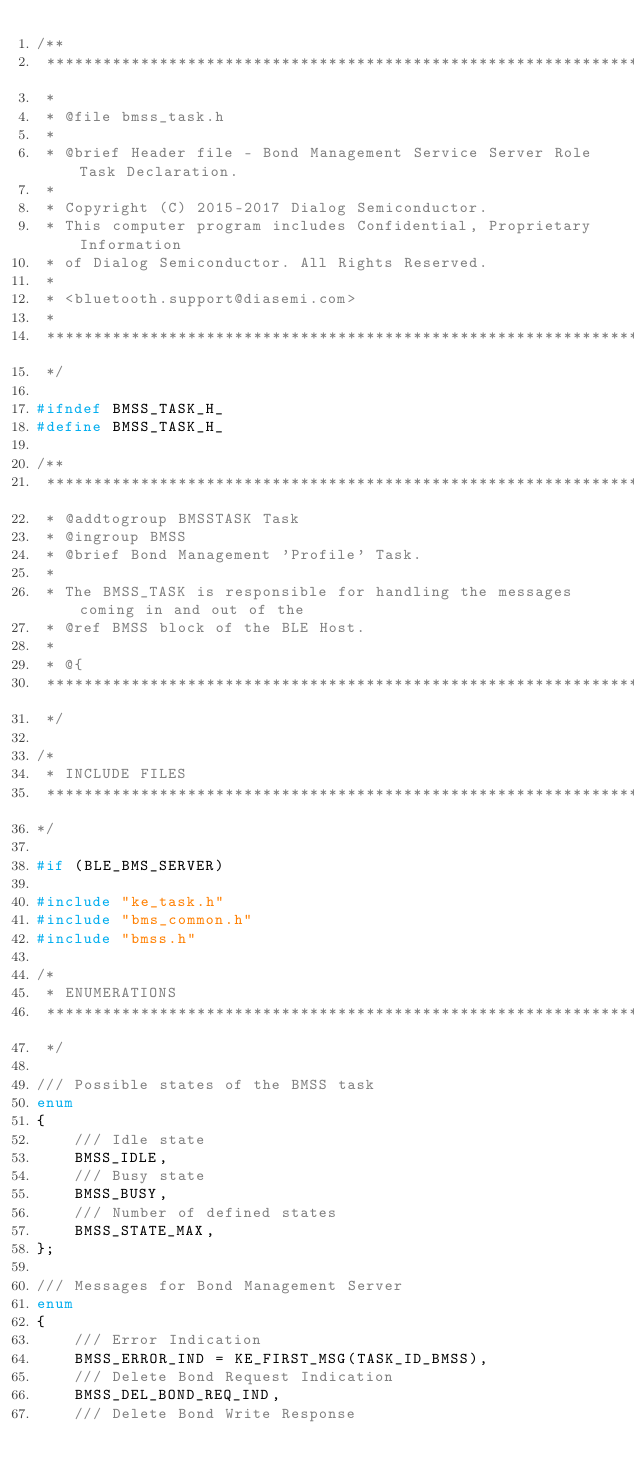Convert code to text. <code><loc_0><loc_0><loc_500><loc_500><_C_>/**
 ****************************************************************************************
 *
 * @file bmss_task.h
 *
 * @brief Header file - Bond Management Service Server Role Task Declaration.
 *
 * Copyright (C) 2015-2017 Dialog Semiconductor.
 * This computer program includes Confidential, Proprietary Information
 * of Dialog Semiconductor. All Rights Reserved.
 *
 * <bluetooth.support@diasemi.com>
 *
 ****************************************************************************************
 */

#ifndef BMSS_TASK_H_
#define BMSS_TASK_H_

/**
 ****************************************************************************************
 * @addtogroup BMSSTASK Task
 * @ingroup BMSS
 * @brief Bond Management 'Profile' Task.
 *
 * The BMSS_TASK is responsible for handling the messages coming in and out of the
 * @ref BMSS block of the BLE Host.
 *
 * @{
 ****************************************************************************************
 */

/*
 * INCLUDE FILES
 ****************************************************************************************
*/

#if (BLE_BMS_SERVER)

#include "ke_task.h"
#include "bms_common.h"
#include "bmss.h"

/*
 * ENUMERATIONS
 ****************************************************************************************
 */

/// Possible states of the BMSS task
enum
{
    /// Idle state
    BMSS_IDLE,
    /// Busy state
    BMSS_BUSY,
    /// Number of defined states
    BMSS_STATE_MAX,
};

/// Messages for Bond Management Server
enum
{
    /// Error Indication
    BMSS_ERROR_IND = KE_FIRST_MSG(TASK_ID_BMSS),
    /// Delete Bond Request Indication
    BMSS_DEL_BOND_REQ_IND,
    /// Delete Bond Write Response</code> 